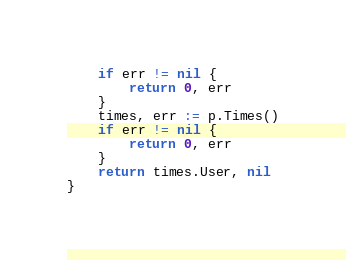<code> <loc_0><loc_0><loc_500><loc_500><_Go_>	if err != nil {
		return 0, err
	}
	times, err := p.Times()
	if err != nil {
		return 0, err
	}
	return times.User, nil
}
</code> 